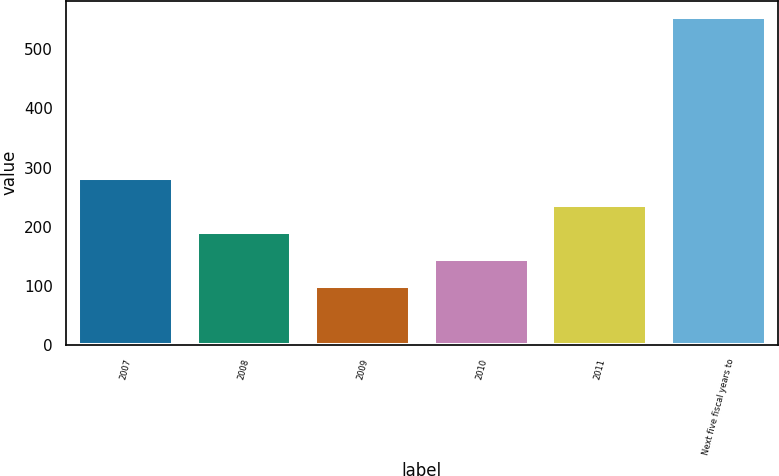Convert chart. <chart><loc_0><loc_0><loc_500><loc_500><bar_chart><fcel>2007<fcel>2008<fcel>2009<fcel>2010<fcel>2011<fcel>Next five fiscal years to<nl><fcel>282<fcel>191<fcel>100<fcel>145.5<fcel>236.5<fcel>555<nl></chart> 